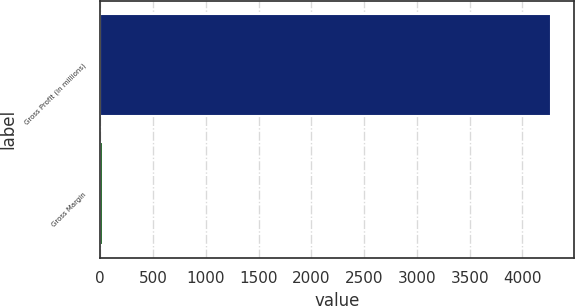Convert chart. <chart><loc_0><loc_0><loc_500><loc_500><bar_chart><fcel>Gross Profit (in millions)<fcel>Gross Margin<nl><fcel>4270<fcel>22.3<nl></chart> 